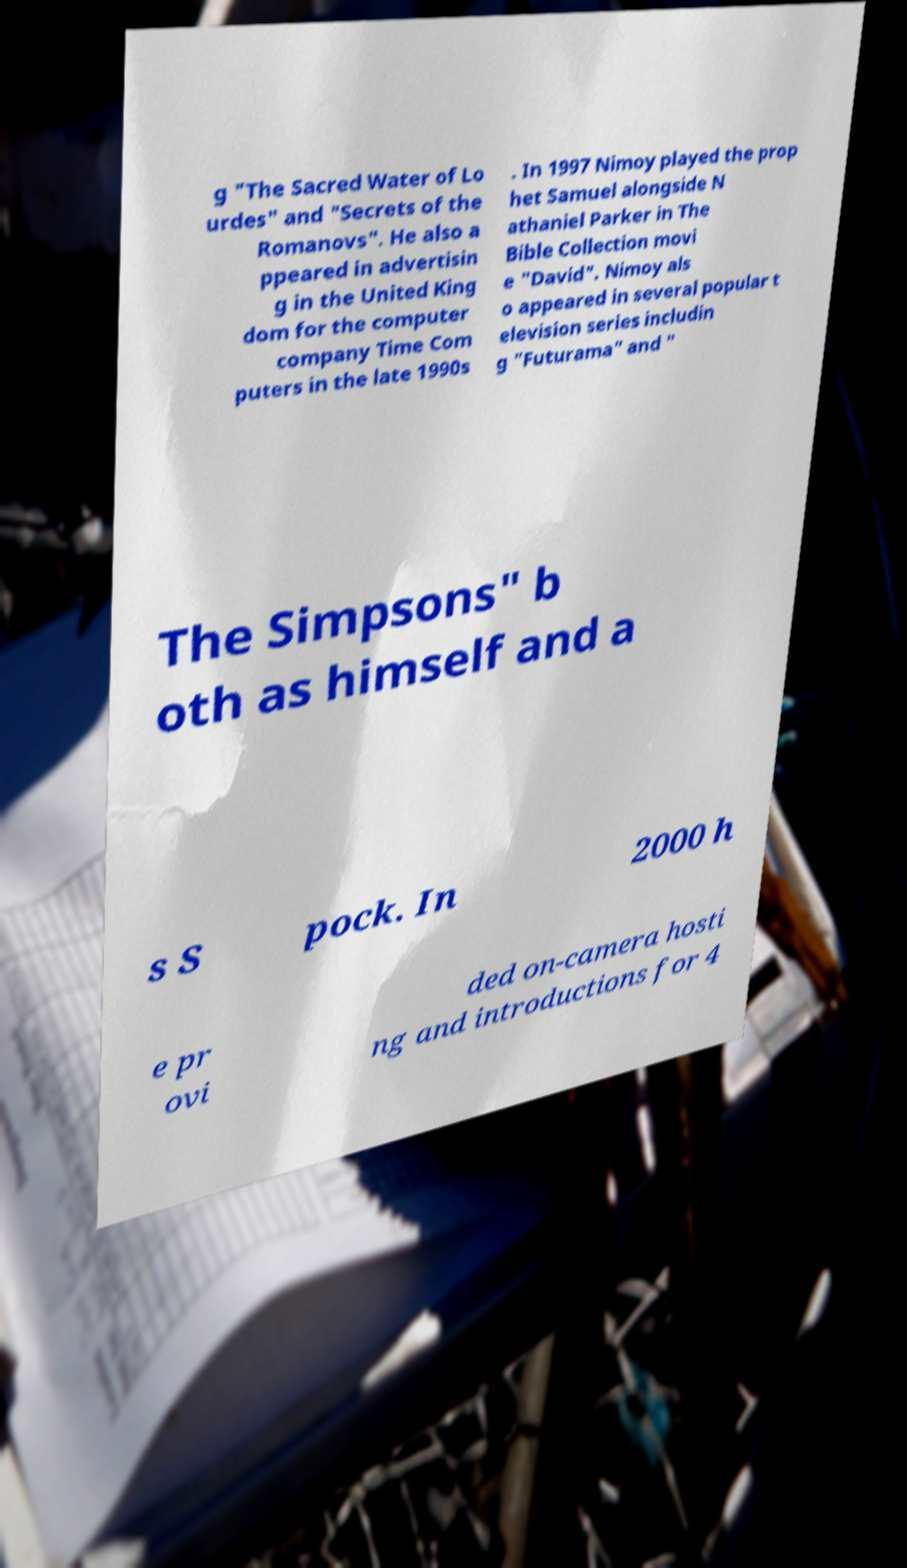Please read and relay the text visible in this image. What does it say? g "The Sacred Water of Lo urdes" and "Secrets of the Romanovs". He also a ppeared in advertisin g in the United King dom for the computer company Time Com puters in the late 1990s . In 1997 Nimoy played the prop het Samuel alongside N athaniel Parker in The Bible Collection movi e "David". Nimoy als o appeared in several popular t elevision series includin g "Futurama" and " The Simpsons" b oth as himself and a s S pock. In 2000 h e pr ovi ded on-camera hosti ng and introductions for 4 